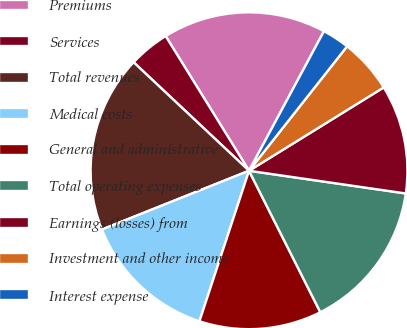Convert chart. <chart><loc_0><loc_0><loc_500><loc_500><pie_chart><fcel>Premiums<fcel>Services<fcel>Total revenues<fcel>Medical costs<fcel>General and administrative<fcel>Total operating expenses<fcel>Earnings (losses) from<fcel>Investment and other income<fcel>Interest expense<nl><fcel>16.67%<fcel>4.17%<fcel>18.06%<fcel>13.89%<fcel>12.5%<fcel>15.28%<fcel>11.11%<fcel>5.56%<fcel>2.78%<nl></chart> 